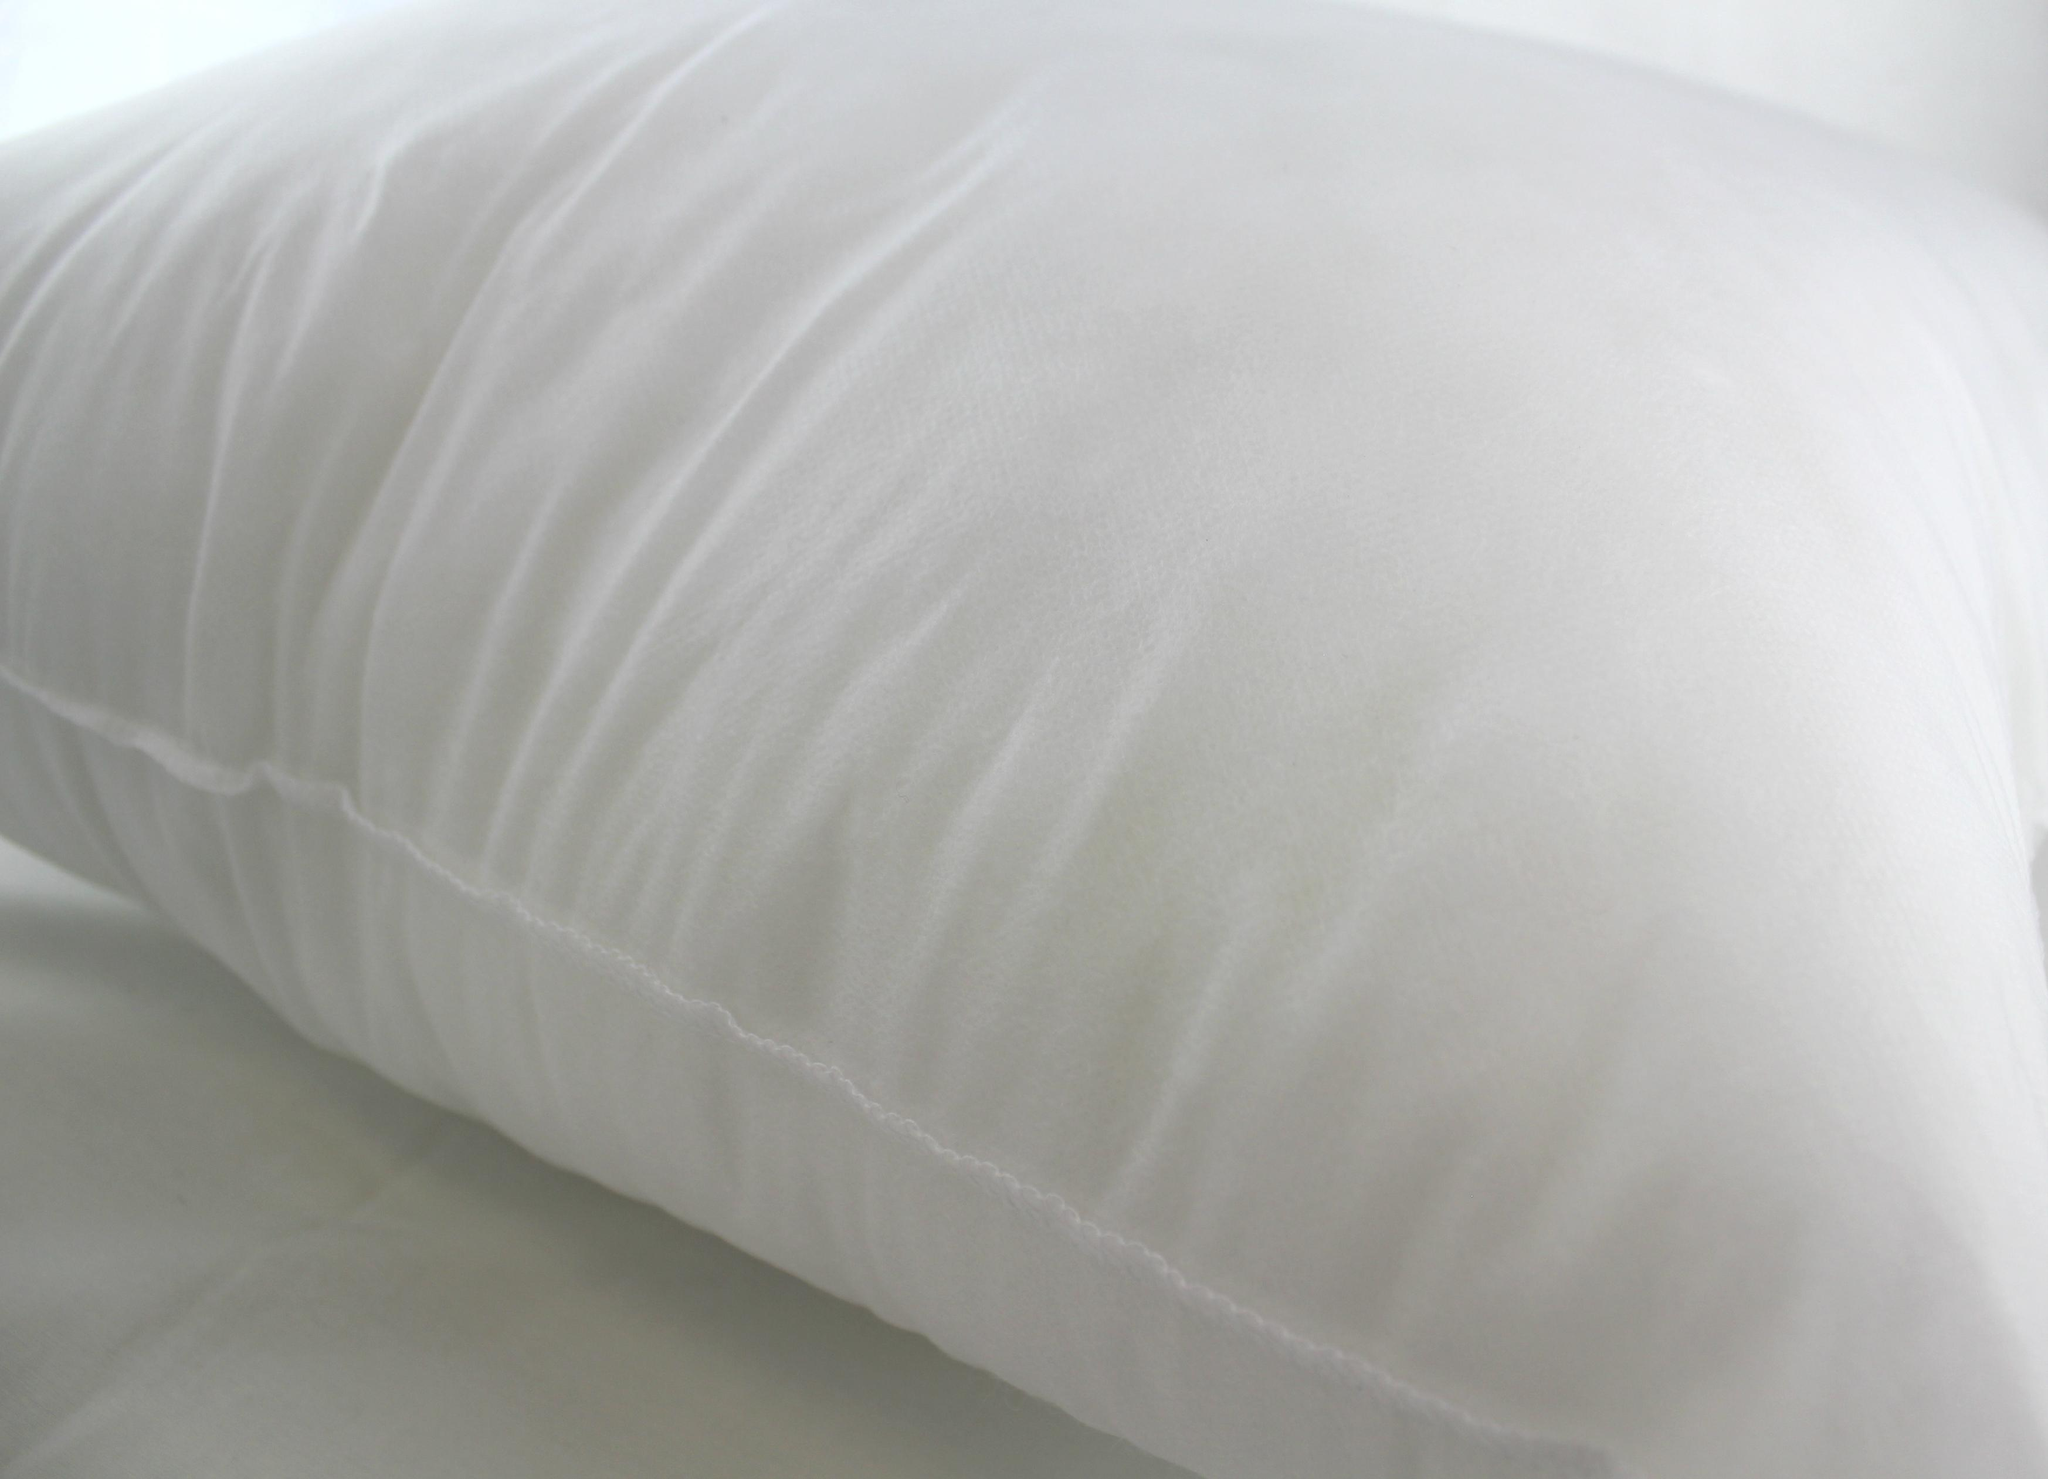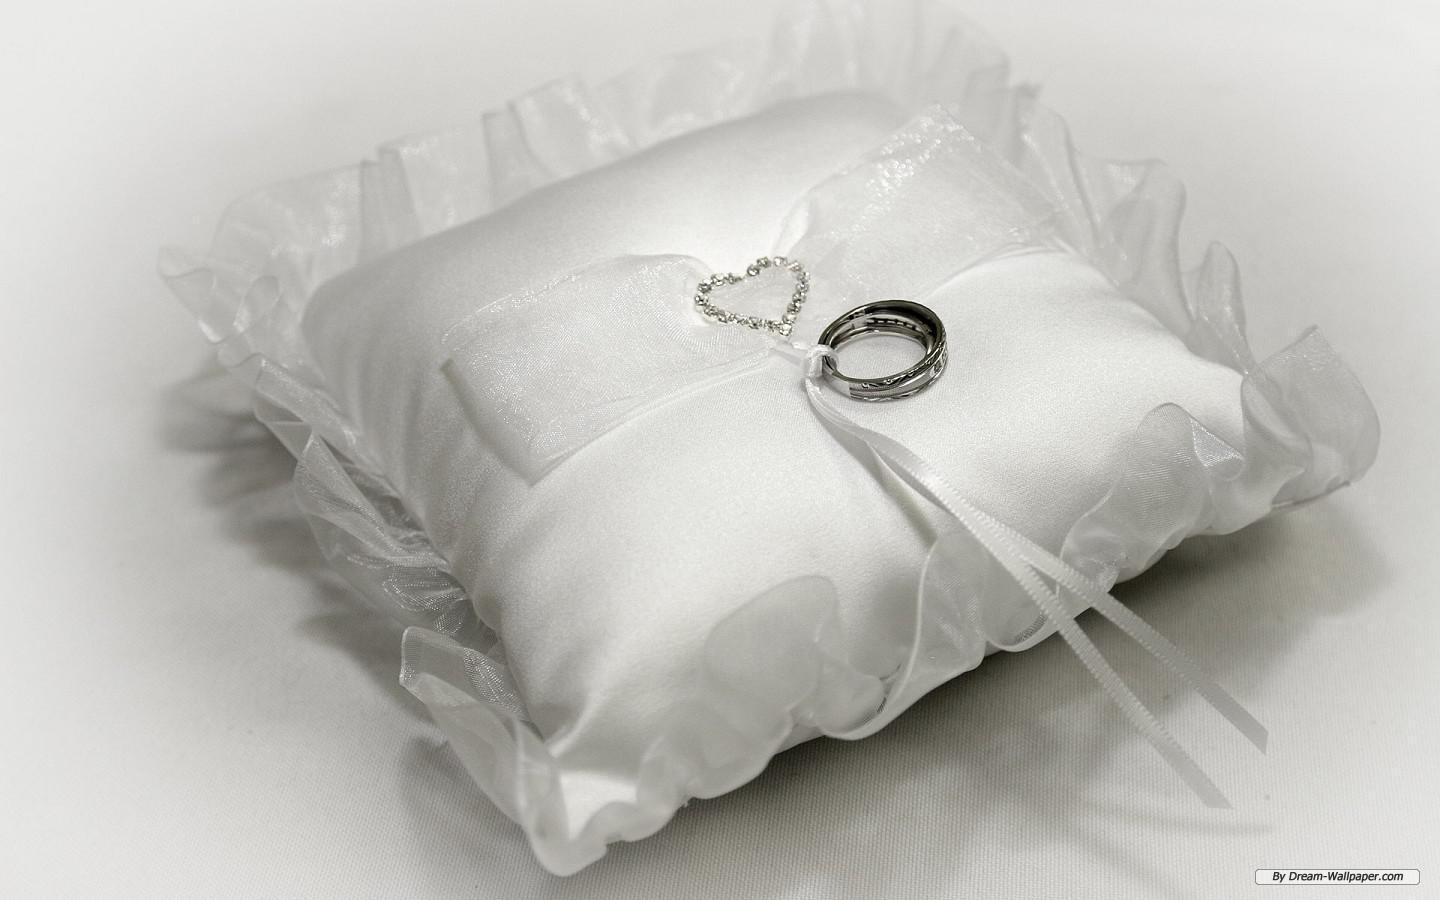The first image is the image on the left, the second image is the image on the right. For the images shown, is this caption "An image includes a pile of at least 10 white pillows." true? Answer yes or no. No. The first image is the image on the left, the second image is the image on the right. Assess this claim about the two images: "There is a single uncovered pillow in the left image.". Correct or not? Answer yes or no. Yes. 